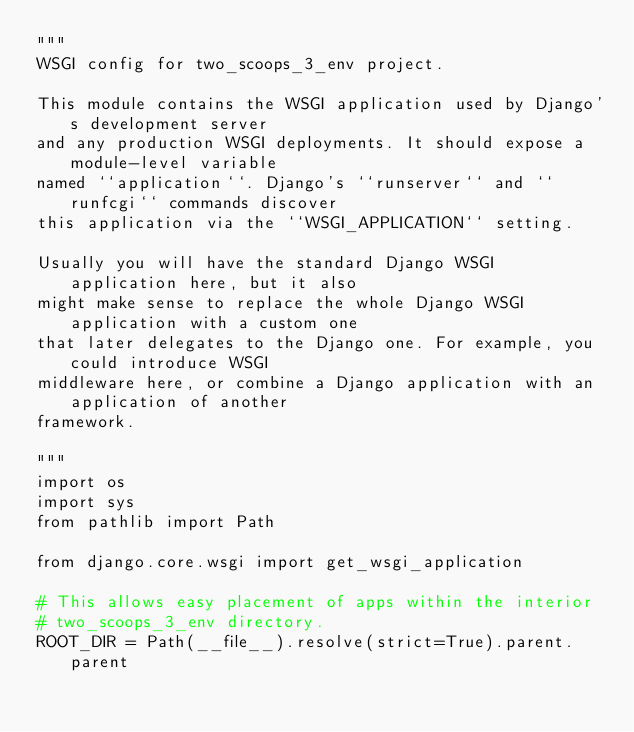Convert code to text. <code><loc_0><loc_0><loc_500><loc_500><_Python_>"""
WSGI config for two_scoops_3_env project.

This module contains the WSGI application used by Django's development server
and any production WSGI deployments. It should expose a module-level variable
named ``application``. Django's ``runserver`` and ``runfcgi`` commands discover
this application via the ``WSGI_APPLICATION`` setting.

Usually you will have the standard Django WSGI application here, but it also
might make sense to replace the whole Django WSGI application with a custom one
that later delegates to the Django one. For example, you could introduce WSGI
middleware here, or combine a Django application with an application of another
framework.

"""
import os
import sys
from pathlib import Path

from django.core.wsgi import get_wsgi_application

# This allows easy placement of apps within the interior
# two_scoops_3_env directory.
ROOT_DIR = Path(__file__).resolve(strict=True).parent.parent</code> 